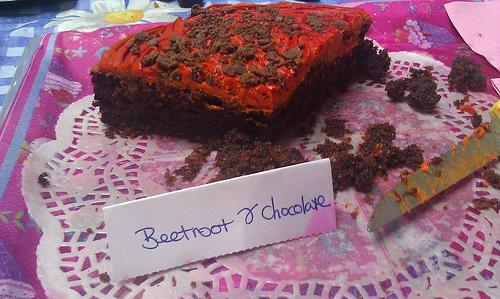Rank the elements in the image by their sizes (width x height), starting with the smallest. (text will be truncated due to character limit) What could be the special ingredient in the cake, as mentioned in the sign? The special ingredient in the cake could be beetroot, as mentioned in the sign. Assess the overall quality and presentation of the image. The image has a good quality and presentation, with a clear focus on the beetroot chocolate cake and its various elements, accompanied by a warm color scheme. Count the number of objects related to the cake itself in the image. There are 15 objects related to the cake itself in the image, including various elements of its description, frosting, and crumbs. Discuss any patterns or designs on the tablecloth in the image. The tablecloth in the image features a daisy pattern and appears to have a white flower on it, providing an elegant and inviting background for the cake centerpiece. Explain what is written on the white sign in the image and its relation to the cake. The white sign contains the words "beetroot" and "chocolate," which suggest that the cake is a beetroot chocolate flavored cake. Describe the interaction of the knife with the cake in the image. The knife in the image is beside the cake, covered in orange frosting and cake crumbs, indicating that it has been used to cut or serve the cake. What are the words on the white sign with blue printing in the image? The words on the white sign with blue printing are "beetroot" and "chocolate." State the emotions and feelings that the image might evoke. The image may evoke feelings of satisfaction and indulgence due to the beetroot chocolate cake and a sense of comfort from the warm color palette. 